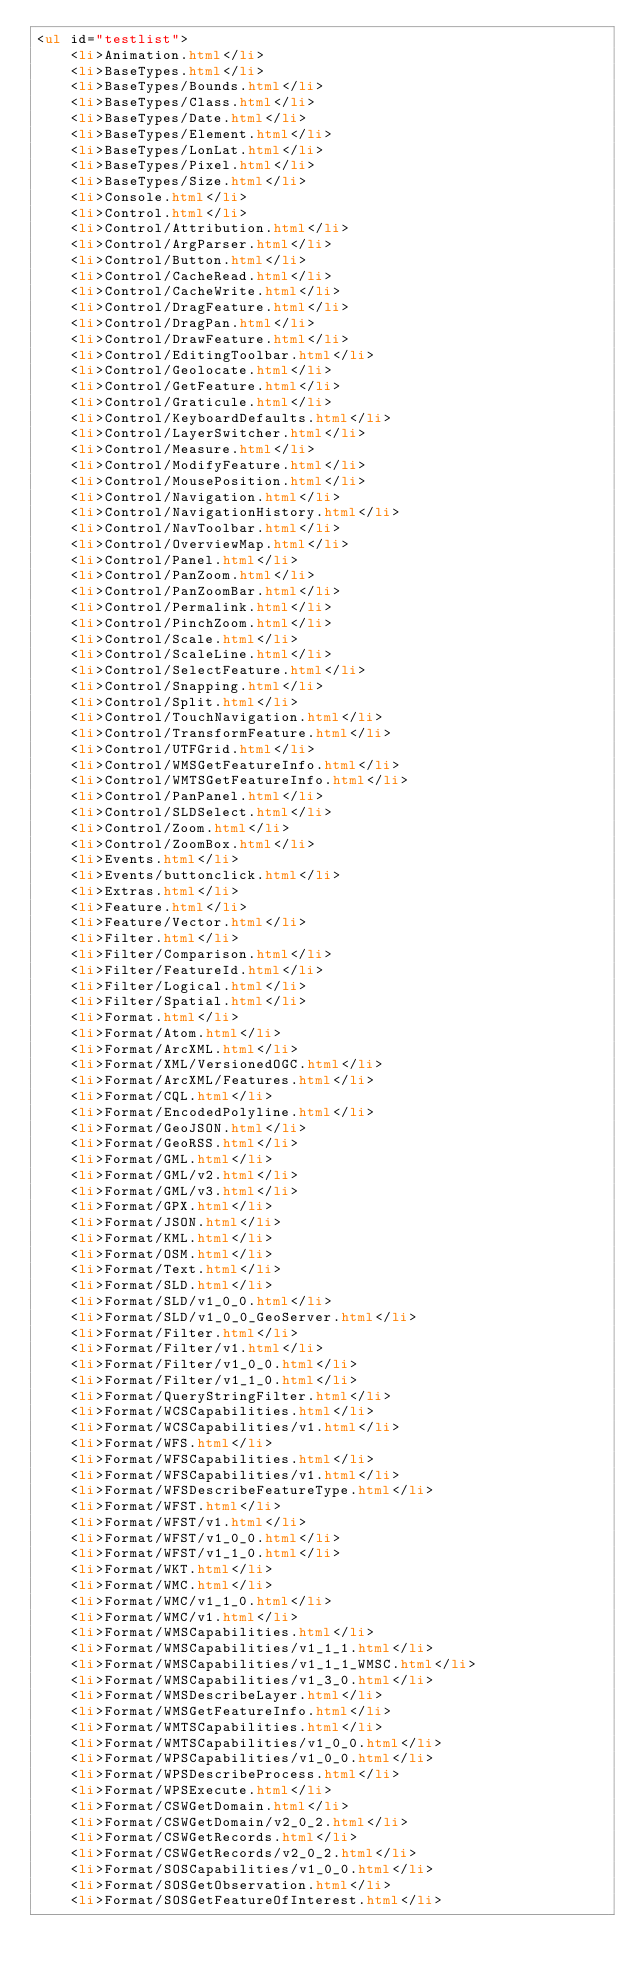<code> <loc_0><loc_0><loc_500><loc_500><_HTML_><ul id="testlist">
    <li>Animation.html</li>
    <li>BaseTypes.html</li>
    <li>BaseTypes/Bounds.html</li>
    <li>BaseTypes/Class.html</li>
    <li>BaseTypes/Date.html</li>
    <li>BaseTypes/Element.html</li>
    <li>BaseTypes/LonLat.html</li>
    <li>BaseTypes/Pixel.html</li>
    <li>BaseTypes/Size.html</li>
    <li>Console.html</li>
    <li>Control.html</li>
    <li>Control/Attribution.html</li>
    <li>Control/ArgParser.html</li>
    <li>Control/Button.html</li>
    <li>Control/CacheRead.html</li>
    <li>Control/CacheWrite.html</li>
    <li>Control/DragFeature.html</li>
    <li>Control/DragPan.html</li>
    <li>Control/DrawFeature.html</li>
    <li>Control/EditingToolbar.html</li>
    <li>Control/Geolocate.html</li>
    <li>Control/GetFeature.html</li>
    <li>Control/Graticule.html</li>
    <li>Control/KeyboardDefaults.html</li>
    <li>Control/LayerSwitcher.html</li>
    <li>Control/Measure.html</li>
    <li>Control/ModifyFeature.html</li>
    <li>Control/MousePosition.html</li>
    <li>Control/Navigation.html</li>
    <li>Control/NavigationHistory.html</li>
    <li>Control/NavToolbar.html</li>
    <li>Control/OverviewMap.html</li>
    <li>Control/Panel.html</li>
    <li>Control/PanZoom.html</li>
    <li>Control/PanZoomBar.html</li>
    <li>Control/Permalink.html</li>
    <li>Control/PinchZoom.html</li>
    <li>Control/Scale.html</li>
    <li>Control/ScaleLine.html</li>
    <li>Control/SelectFeature.html</li>
    <li>Control/Snapping.html</li>
    <li>Control/Split.html</li>
    <li>Control/TouchNavigation.html</li>
    <li>Control/TransformFeature.html</li>
    <li>Control/UTFGrid.html</li>
    <li>Control/WMSGetFeatureInfo.html</li>
    <li>Control/WMTSGetFeatureInfo.html</li>
    <li>Control/PanPanel.html</li>
    <li>Control/SLDSelect.html</li>
    <li>Control/Zoom.html</li>
    <li>Control/ZoomBox.html</li>
    <li>Events.html</li>
    <li>Events/buttonclick.html</li>
    <li>Extras.html</li>
    <li>Feature.html</li>
    <li>Feature/Vector.html</li>
    <li>Filter.html</li>
    <li>Filter/Comparison.html</li>
    <li>Filter/FeatureId.html</li>
    <li>Filter/Logical.html</li>
    <li>Filter/Spatial.html</li>
    <li>Format.html</li>
    <li>Format/Atom.html</li>
    <li>Format/ArcXML.html</li>
    <li>Format/XML/VersionedOGC.html</li>
    <li>Format/ArcXML/Features.html</li>
    <li>Format/CQL.html</li>
    <li>Format/EncodedPolyline.html</li>
    <li>Format/GeoJSON.html</li>
    <li>Format/GeoRSS.html</li>
    <li>Format/GML.html</li>
    <li>Format/GML/v2.html</li>
    <li>Format/GML/v3.html</li>
    <li>Format/GPX.html</li>
    <li>Format/JSON.html</li>
    <li>Format/KML.html</li>
    <li>Format/OSM.html</li>
    <li>Format/Text.html</li>
    <li>Format/SLD.html</li>
    <li>Format/SLD/v1_0_0.html</li>
    <li>Format/SLD/v1_0_0_GeoServer.html</li>
    <li>Format/Filter.html</li>
    <li>Format/Filter/v1.html</li>
    <li>Format/Filter/v1_0_0.html</li>
    <li>Format/Filter/v1_1_0.html</li>
    <li>Format/QueryStringFilter.html</li>
    <li>Format/WCSCapabilities.html</li>
    <li>Format/WCSCapabilities/v1.html</li>
    <li>Format/WFS.html</li>
    <li>Format/WFSCapabilities.html</li>
    <li>Format/WFSCapabilities/v1.html</li>
    <li>Format/WFSDescribeFeatureType.html</li>
    <li>Format/WFST.html</li>
    <li>Format/WFST/v1.html</li>
    <li>Format/WFST/v1_0_0.html</li>
    <li>Format/WFST/v1_1_0.html</li>
    <li>Format/WKT.html</li>
    <li>Format/WMC.html</li>
    <li>Format/WMC/v1_1_0.html</li>
    <li>Format/WMC/v1.html</li>
    <li>Format/WMSCapabilities.html</li>
    <li>Format/WMSCapabilities/v1_1_1.html</li>
    <li>Format/WMSCapabilities/v1_1_1_WMSC.html</li>
    <li>Format/WMSCapabilities/v1_3_0.html</li>
    <li>Format/WMSDescribeLayer.html</li>
    <li>Format/WMSGetFeatureInfo.html</li>
    <li>Format/WMTSCapabilities.html</li>
    <li>Format/WMTSCapabilities/v1_0_0.html</li>
    <li>Format/WPSCapabilities/v1_0_0.html</li>
    <li>Format/WPSDescribeProcess.html</li>
    <li>Format/WPSExecute.html</li>
    <li>Format/CSWGetDomain.html</li>
    <li>Format/CSWGetDomain/v2_0_2.html</li>
    <li>Format/CSWGetRecords.html</li>
    <li>Format/CSWGetRecords/v2_0_2.html</li>
    <li>Format/SOSCapabilities/v1_0_0.html</li>
    <li>Format/SOSGetObservation.html</li>
    <li>Format/SOSGetFeatureOfInterest.html</li></code> 